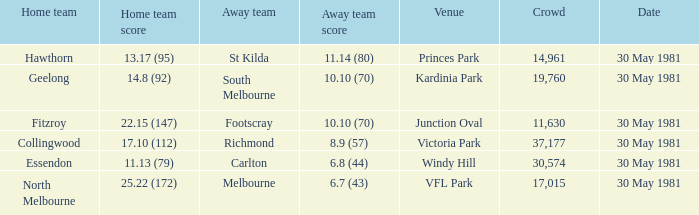What was carlton's score while he was away? 6.8 (44). 